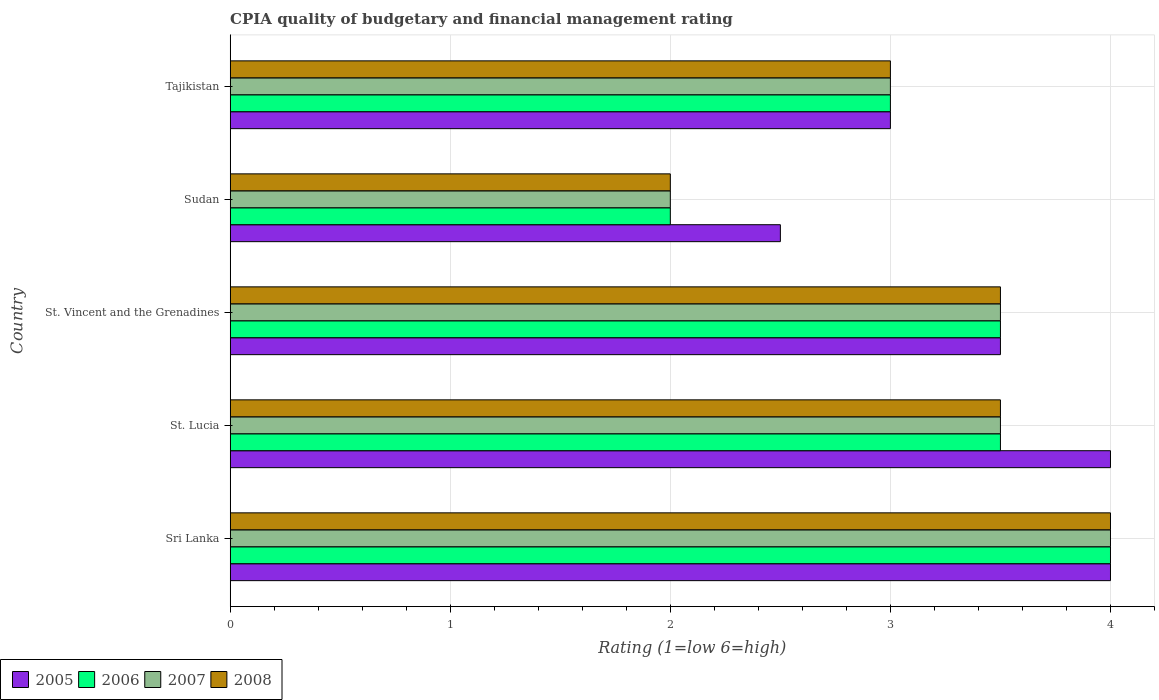Are the number of bars on each tick of the Y-axis equal?
Make the answer very short. Yes. How many bars are there on the 3rd tick from the top?
Make the answer very short. 4. How many bars are there on the 5th tick from the bottom?
Provide a succinct answer. 4. What is the label of the 4th group of bars from the top?
Your response must be concise. St. Lucia. In which country was the CPIA rating in 2008 maximum?
Your response must be concise. Sri Lanka. In which country was the CPIA rating in 2005 minimum?
Give a very brief answer. Sudan. What is the total CPIA rating in 2008 in the graph?
Provide a succinct answer. 16. What is the average CPIA rating in 2008 per country?
Keep it short and to the point. 3.2. What is the ratio of the CPIA rating in 2006 in St. Vincent and the Grenadines to that in Tajikistan?
Offer a terse response. 1.17. Is the CPIA rating in 2007 in Sri Lanka less than that in St. Vincent and the Grenadines?
Give a very brief answer. No. Is it the case that in every country, the sum of the CPIA rating in 2005 and CPIA rating in 2006 is greater than the sum of CPIA rating in 2007 and CPIA rating in 2008?
Keep it short and to the point. No. What does the 1st bar from the top in Tajikistan represents?
Your response must be concise. 2008. What does the 2nd bar from the bottom in Tajikistan represents?
Provide a succinct answer. 2006. Is it the case that in every country, the sum of the CPIA rating in 2006 and CPIA rating in 2008 is greater than the CPIA rating in 2007?
Your answer should be very brief. Yes. How many bars are there?
Keep it short and to the point. 20. How many countries are there in the graph?
Provide a short and direct response. 5. What is the difference between two consecutive major ticks on the X-axis?
Offer a very short reply. 1. Are the values on the major ticks of X-axis written in scientific E-notation?
Your answer should be compact. No. Where does the legend appear in the graph?
Your answer should be compact. Bottom left. How many legend labels are there?
Offer a very short reply. 4. What is the title of the graph?
Offer a very short reply. CPIA quality of budgetary and financial management rating. Does "2005" appear as one of the legend labels in the graph?
Provide a succinct answer. Yes. What is the label or title of the X-axis?
Offer a terse response. Rating (1=low 6=high). What is the Rating (1=low 6=high) in 2006 in Sri Lanka?
Make the answer very short. 4. What is the Rating (1=low 6=high) in 2007 in Sri Lanka?
Your response must be concise. 4. What is the Rating (1=low 6=high) in 2008 in Sri Lanka?
Your answer should be very brief. 4. What is the Rating (1=low 6=high) in 2005 in St. Lucia?
Provide a short and direct response. 4. What is the Rating (1=low 6=high) of 2007 in St. Lucia?
Provide a short and direct response. 3.5. What is the Rating (1=low 6=high) in 2008 in St. Lucia?
Make the answer very short. 3.5. What is the Rating (1=low 6=high) of 2005 in St. Vincent and the Grenadines?
Your answer should be very brief. 3.5. What is the Rating (1=low 6=high) in 2006 in St. Vincent and the Grenadines?
Ensure brevity in your answer.  3.5. What is the Rating (1=low 6=high) of 2007 in St. Vincent and the Grenadines?
Offer a very short reply. 3.5. What is the Rating (1=low 6=high) of 2007 in Sudan?
Offer a terse response. 2. What is the Rating (1=low 6=high) in 2005 in Tajikistan?
Your answer should be very brief. 3. What is the Rating (1=low 6=high) in 2008 in Tajikistan?
Provide a short and direct response. 3. Across all countries, what is the maximum Rating (1=low 6=high) in 2005?
Offer a terse response. 4. Across all countries, what is the maximum Rating (1=low 6=high) of 2008?
Keep it short and to the point. 4. Across all countries, what is the minimum Rating (1=low 6=high) in 2005?
Keep it short and to the point. 2.5. Across all countries, what is the minimum Rating (1=low 6=high) in 2006?
Ensure brevity in your answer.  2. Across all countries, what is the minimum Rating (1=low 6=high) in 2008?
Keep it short and to the point. 2. What is the total Rating (1=low 6=high) of 2005 in the graph?
Your answer should be very brief. 17. What is the total Rating (1=low 6=high) in 2006 in the graph?
Offer a terse response. 16. What is the total Rating (1=low 6=high) of 2008 in the graph?
Your answer should be compact. 16. What is the difference between the Rating (1=low 6=high) of 2006 in Sri Lanka and that in St. Lucia?
Make the answer very short. 0.5. What is the difference between the Rating (1=low 6=high) in 2007 in Sri Lanka and that in St. Lucia?
Offer a very short reply. 0.5. What is the difference between the Rating (1=low 6=high) of 2006 in Sri Lanka and that in St. Vincent and the Grenadines?
Your answer should be very brief. 0.5. What is the difference between the Rating (1=low 6=high) in 2007 in Sri Lanka and that in St. Vincent and the Grenadines?
Keep it short and to the point. 0.5. What is the difference between the Rating (1=low 6=high) of 2008 in Sri Lanka and that in St. Vincent and the Grenadines?
Provide a succinct answer. 0.5. What is the difference between the Rating (1=low 6=high) of 2007 in Sri Lanka and that in Sudan?
Make the answer very short. 2. What is the difference between the Rating (1=low 6=high) of 2006 in St. Lucia and that in St. Vincent and the Grenadines?
Offer a terse response. 0. What is the difference between the Rating (1=low 6=high) of 2007 in St. Lucia and that in St. Vincent and the Grenadines?
Offer a very short reply. 0. What is the difference between the Rating (1=low 6=high) in 2005 in St. Lucia and that in Sudan?
Your answer should be compact. 1.5. What is the difference between the Rating (1=low 6=high) of 2008 in St. Lucia and that in Sudan?
Offer a terse response. 1.5. What is the difference between the Rating (1=low 6=high) of 2006 in St. Lucia and that in Tajikistan?
Keep it short and to the point. 0.5. What is the difference between the Rating (1=low 6=high) of 2008 in St. Lucia and that in Tajikistan?
Keep it short and to the point. 0.5. What is the difference between the Rating (1=low 6=high) of 2005 in St. Vincent and the Grenadines and that in Sudan?
Ensure brevity in your answer.  1. What is the difference between the Rating (1=low 6=high) in 2006 in St. Vincent and the Grenadines and that in Sudan?
Offer a very short reply. 1.5. What is the difference between the Rating (1=low 6=high) in 2005 in St. Vincent and the Grenadines and that in Tajikistan?
Provide a short and direct response. 0.5. What is the difference between the Rating (1=low 6=high) of 2007 in St. Vincent and the Grenadines and that in Tajikistan?
Your answer should be very brief. 0.5. What is the difference between the Rating (1=low 6=high) of 2005 in Sri Lanka and the Rating (1=low 6=high) of 2008 in St. Lucia?
Offer a terse response. 0.5. What is the difference between the Rating (1=low 6=high) in 2006 in Sri Lanka and the Rating (1=low 6=high) in 2007 in St. Lucia?
Your response must be concise. 0.5. What is the difference between the Rating (1=low 6=high) in 2007 in Sri Lanka and the Rating (1=low 6=high) in 2008 in St. Lucia?
Give a very brief answer. 0.5. What is the difference between the Rating (1=low 6=high) in 2005 in Sri Lanka and the Rating (1=low 6=high) in 2006 in St. Vincent and the Grenadines?
Your answer should be compact. 0.5. What is the difference between the Rating (1=low 6=high) of 2005 in Sri Lanka and the Rating (1=low 6=high) of 2007 in St. Vincent and the Grenadines?
Offer a terse response. 0.5. What is the difference between the Rating (1=low 6=high) of 2005 in Sri Lanka and the Rating (1=low 6=high) of 2008 in St. Vincent and the Grenadines?
Provide a succinct answer. 0.5. What is the difference between the Rating (1=low 6=high) in 2007 in Sri Lanka and the Rating (1=low 6=high) in 2008 in St. Vincent and the Grenadines?
Provide a succinct answer. 0.5. What is the difference between the Rating (1=low 6=high) in 2005 in Sri Lanka and the Rating (1=low 6=high) in 2006 in Sudan?
Ensure brevity in your answer.  2. What is the difference between the Rating (1=low 6=high) of 2005 in Sri Lanka and the Rating (1=low 6=high) of 2008 in Sudan?
Make the answer very short. 2. What is the difference between the Rating (1=low 6=high) in 2006 in Sri Lanka and the Rating (1=low 6=high) in 2008 in Sudan?
Provide a short and direct response. 2. What is the difference between the Rating (1=low 6=high) of 2005 in Sri Lanka and the Rating (1=low 6=high) of 2007 in Tajikistan?
Provide a short and direct response. 1. What is the difference between the Rating (1=low 6=high) of 2005 in Sri Lanka and the Rating (1=low 6=high) of 2008 in Tajikistan?
Offer a terse response. 1. What is the difference between the Rating (1=low 6=high) of 2007 in Sri Lanka and the Rating (1=low 6=high) of 2008 in Tajikistan?
Offer a very short reply. 1. What is the difference between the Rating (1=low 6=high) of 2005 in St. Lucia and the Rating (1=low 6=high) of 2007 in St. Vincent and the Grenadines?
Give a very brief answer. 0.5. What is the difference between the Rating (1=low 6=high) of 2005 in St. Lucia and the Rating (1=low 6=high) of 2008 in St. Vincent and the Grenadines?
Provide a succinct answer. 0.5. What is the difference between the Rating (1=low 6=high) in 2006 in St. Lucia and the Rating (1=low 6=high) in 2008 in St. Vincent and the Grenadines?
Keep it short and to the point. 0. What is the difference between the Rating (1=low 6=high) of 2007 in St. Lucia and the Rating (1=low 6=high) of 2008 in St. Vincent and the Grenadines?
Your answer should be compact. 0. What is the difference between the Rating (1=low 6=high) in 2005 in St. Lucia and the Rating (1=low 6=high) in 2006 in Sudan?
Offer a terse response. 2. What is the difference between the Rating (1=low 6=high) of 2005 in St. Lucia and the Rating (1=low 6=high) of 2007 in Sudan?
Keep it short and to the point. 2. What is the difference between the Rating (1=low 6=high) of 2005 in St. Lucia and the Rating (1=low 6=high) of 2008 in Sudan?
Make the answer very short. 2. What is the difference between the Rating (1=low 6=high) in 2006 in St. Lucia and the Rating (1=low 6=high) in 2007 in Sudan?
Ensure brevity in your answer.  1.5. What is the difference between the Rating (1=low 6=high) in 2006 in St. Lucia and the Rating (1=low 6=high) in 2008 in Sudan?
Offer a terse response. 1.5. What is the difference between the Rating (1=low 6=high) of 2007 in St. Lucia and the Rating (1=low 6=high) of 2008 in Sudan?
Your answer should be very brief. 1.5. What is the difference between the Rating (1=low 6=high) in 2005 in St. Lucia and the Rating (1=low 6=high) in 2006 in Tajikistan?
Your answer should be very brief. 1. What is the difference between the Rating (1=low 6=high) in 2005 in St. Lucia and the Rating (1=low 6=high) in 2007 in Tajikistan?
Offer a very short reply. 1. What is the difference between the Rating (1=low 6=high) in 2005 in St. Lucia and the Rating (1=low 6=high) in 2008 in Tajikistan?
Provide a succinct answer. 1. What is the difference between the Rating (1=low 6=high) of 2006 in St. Lucia and the Rating (1=low 6=high) of 2007 in Tajikistan?
Your answer should be compact. 0.5. What is the difference between the Rating (1=low 6=high) in 2006 in St. Lucia and the Rating (1=low 6=high) in 2008 in Tajikistan?
Offer a very short reply. 0.5. What is the difference between the Rating (1=low 6=high) in 2005 in St. Vincent and the Grenadines and the Rating (1=low 6=high) in 2006 in Sudan?
Keep it short and to the point. 1.5. What is the difference between the Rating (1=low 6=high) in 2005 in St. Vincent and the Grenadines and the Rating (1=low 6=high) in 2006 in Tajikistan?
Make the answer very short. 0.5. What is the difference between the Rating (1=low 6=high) in 2006 in St. Vincent and the Grenadines and the Rating (1=low 6=high) in 2007 in Tajikistan?
Your answer should be compact. 0.5. What is the difference between the Rating (1=low 6=high) in 2007 in St. Vincent and the Grenadines and the Rating (1=low 6=high) in 2008 in Tajikistan?
Ensure brevity in your answer.  0.5. What is the difference between the Rating (1=low 6=high) in 2005 in Sudan and the Rating (1=low 6=high) in 2008 in Tajikistan?
Make the answer very short. -0.5. What is the difference between the Rating (1=low 6=high) of 2006 in Sudan and the Rating (1=low 6=high) of 2008 in Tajikistan?
Offer a very short reply. -1. What is the difference between the Rating (1=low 6=high) in 2007 in Sudan and the Rating (1=low 6=high) in 2008 in Tajikistan?
Ensure brevity in your answer.  -1. What is the difference between the Rating (1=low 6=high) of 2005 and Rating (1=low 6=high) of 2007 in Sri Lanka?
Offer a terse response. 0. What is the difference between the Rating (1=low 6=high) of 2005 and Rating (1=low 6=high) of 2008 in Sri Lanka?
Make the answer very short. 0. What is the difference between the Rating (1=low 6=high) of 2006 and Rating (1=low 6=high) of 2008 in Sri Lanka?
Provide a succinct answer. 0. What is the difference between the Rating (1=low 6=high) of 2007 and Rating (1=low 6=high) of 2008 in Sri Lanka?
Make the answer very short. 0. What is the difference between the Rating (1=low 6=high) in 2005 and Rating (1=low 6=high) in 2007 in St. Lucia?
Provide a succinct answer. 0.5. What is the difference between the Rating (1=low 6=high) in 2005 and Rating (1=low 6=high) in 2008 in St. Lucia?
Your response must be concise. 0.5. What is the difference between the Rating (1=low 6=high) of 2006 and Rating (1=low 6=high) of 2007 in St. Lucia?
Your answer should be very brief. 0. What is the difference between the Rating (1=low 6=high) in 2006 and Rating (1=low 6=high) in 2008 in St. Lucia?
Your answer should be compact. 0. What is the difference between the Rating (1=low 6=high) of 2005 and Rating (1=low 6=high) of 2007 in St. Vincent and the Grenadines?
Provide a succinct answer. 0. What is the difference between the Rating (1=low 6=high) in 2005 and Rating (1=low 6=high) in 2008 in St. Vincent and the Grenadines?
Ensure brevity in your answer.  0. What is the difference between the Rating (1=low 6=high) in 2006 and Rating (1=low 6=high) in 2008 in St. Vincent and the Grenadines?
Your answer should be very brief. 0. What is the difference between the Rating (1=low 6=high) in 2007 and Rating (1=low 6=high) in 2008 in St. Vincent and the Grenadines?
Make the answer very short. 0. What is the difference between the Rating (1=low 6=high) of 2005 and Rating (1=low 6=high) of 2007 in Sudan?
Your response must be concise. 0.5. What is the ratio of the Rating (1=low 6=high) of 2005 in Sri Lanka to that in St. Lucia?
Your response must be concise. 1. What is the ratio of the Rating (1=low 6=high) of 2008 in Sri Lanka to that in St. Lucia?
Provide a succinct answer. 1.14. What is the ratio of the Rating (1=low 6=high) in 2005 in Sri Lanka to that in St. Vincent and the Grenadines?
Give a very brief answer. 1.14. What is the ratio of the Rating (1=low 6=high) in 2007 in Sri Lanka to that in St. Vincent and the Grenadines?
Give a very brief answer. 1.14. What is the ratio of the Rating (1=low 6=high) in 2008 in Sri Lanka to that in St. Vincent and the Grenadines?
Ensure brevity in your answer.  1.14. What is the ratio of the Rating (1=low 6=high) in 2005 in Sri Lanka to that in Sudan?
Offer a very short reply. 1.6. What is the ratio of the Rating (1=low 6=high) of 2006 in Sri Lanka to that in Sudan?
Give a very brief answer. 2. What is the ratio of the Rating (1=low 6=high) of 2008 in Sri Lanka to that in Sudan?
Your answer should be very brief. 2. What is the ratio of the Rating (1=low 6=high) of 2005 in Sri Lanka to that in Tajikistan?
Your answer should be compact. 1.33. What is the ratio of the Rating (1=low 6=high) of 2006 in Sri Lanka to that in Tajikistan?
Make the answer very short. 1.33. What is the ratio of the Rating (1=low 6=high) in 2007 in Sri Lanka to that in Tajikistan?
Your answer should be compact. 1.33. What is the ratio of the Rating (1=low 6=high) in 2008 in Sri Lanka to that in Tajikistan?
Your answer should be very brief. 1.33. What is the ratio of the Rating (1=low 6=high) of 2007 in St. Lucia to that in St. Vincent and the Grenadines?
Your response must be concise. 1. What is the ratio of the Rating (1=low 6=high) in 2006 in St. Lucia to that in Sudan?
Provide a short and direct response. 1.75. What is the ratio of the Rating (1=low 6=high) of 2007 in St. Lucia to that in Sudan?
Ensure brevity in your answer.  1.75. What is the ratio of the Rating (1=low 6=high) of 2008 in St. Lucia to that in Sudan?
Your response must be concise. 1.75. What is the ratio of the Rating (1=low 6=high) in 2006 in St. Lucia to that in Tajikistan?
Your response must be concise. 1.17. What is the ratio of the Rating (1=low 6=high) in 2008 in St. Lucia to that in Tajikistan?
Provide a short and direct response. 1.17. What is the ratio of the Rating (1=low 6=high) in 2007 in St. Vincent and the Grenadines to that in Sudan?
Your response must be concise. 1.75. What is the ratio of the Rating (1=low 6=high) of 2008 in St. Vincent and the Grenadines to that in Sudan?
Provide a short and direct response. 1.75. What is the ratio of the Rating (1=low 6=high) in 2006 in St. Vincent and the Grenadines to that in Tajikistan?
Your answer should be compact. 1.17. What is the ratio of the Rating (1=low 6=high) in 2007 in St. Vincent and the Grenadines to that in Tajikistan?
Provide a short and direct response. 1.17. What is the ratio of the Rating (1=low 6=high) of 2008 in St. Vincent and the Grenadines to that in Tajikistan?
Give a very brief answer. 1.17. What is the ratio of the Rating (1=low 6=high) in 2006 in Sudan to that in Tajikistan?
Ensure brevity in your answer.  0.67. What is the difference between the highest and the second highest Rating (1=low 6=high) in 2005?
Your answer should be very brief. 0. What is the difference between the highest and the second highest Rating (1=low 6=high) in 2006?
Offer a very short reply. 0.5. What is the difference between the highest and the lowest Rating (1=low 6=high) of 2005?
Keep it short and to the point. 1.5. What is the difference between the highest and the lowest Rating (1=low 6=high) in 2006?
Your answer should be very brief. 2. What is the difference between the highest and the lowest Rating (1=low 6=high) in 2007?
Make the answer very short. 2. What is the difference between the highest and the lowest Rating (1=low 6=high) of 2008?
Provide a succinct answer. 2. 